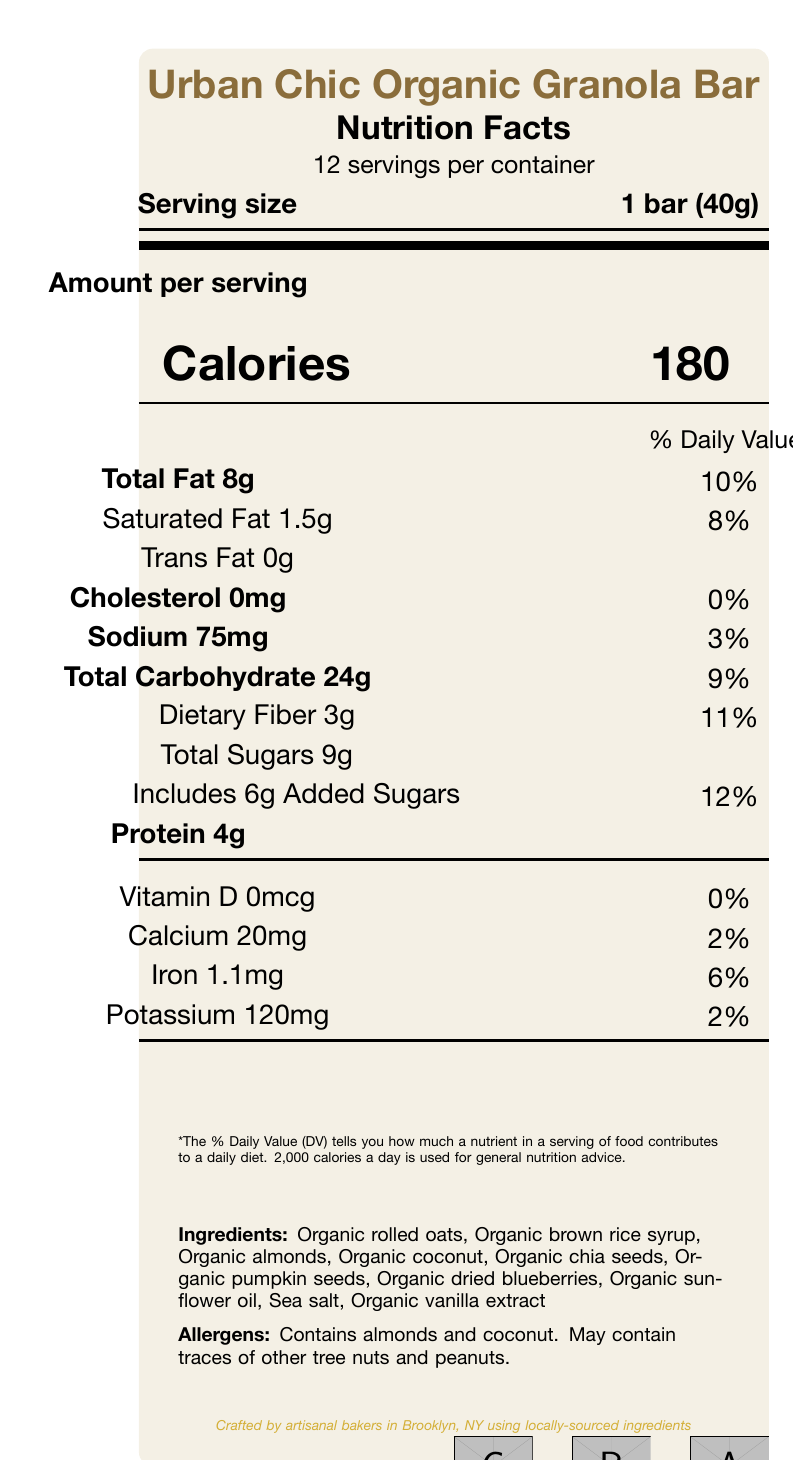What is the serving size for the Urban Chic Organic Granola Bar? The document states that the serving size is "1 bar (40g)."
Answer: 1 bar (40g) How many servings are there per container? It is mentioned that there are "12 servings per container."
Answer: 12 How many calories are in one serving of the granola bar? The document specifies the number of calories per serving as "180."
Answer: 180 What is the total amount of fat in one serving of the granola bar? The total fat amount for one serving is listed as "8g."
Answer: 8g How much sodium is in a single serving? The sodium content per serving is indicated as "75mg."
Answer: 75mg What percentage of the daily value of dietary fiber does one serving provide? The document shows that dietary fiber constitutes "11%" of the daily value in one serving.
Answer: 11% What are the main ingredients in the granola bar? The list of main ingredients is detailed in the document.
Answer: Organic rolled oats, Organic brown rice syrup, Organic almonds, Organic coconut, Organic chia seeds, Organic pumpkin seeds, Organic dried blueberries, Organic sunflower oil, Sea salt, Organic vanilla extract What allergens are mentioned in the granola bar? A. Peanuts B. Walnuts C. Almonds and coconut D. Soy The document specifies that the bar contains "almonds and coconut" and may contain traces of other tree nuts and peanuts.
Answer: C What is the primary color used in the color palette? A. #F4F0E5 B. #D4AF37 C. #8A6D3B D. #123456 The primary color specified is "#8A6D3B."
Answer: C Does the granola bar contain any trans fat? The document clearly states "Trans Fat 0g."
Answer: No How much protein does one granola bar contain? The protein content in one serving is listed as "4g."
Answer: 4g Does the granola bar contain vitamin D? The document indicates that the vitamin D content is "0mcg," equating to "0%."
Answer: No What are the certifications that the granola bar has received? The document lists these certifications under a section for certifications.
Answer: USDA Organic, Non-GMO Project Verified, Fair Trade Certified Describe the packaging of the granola bar. The document notes the packaging as "Recyclable kraft paper wrapper with gold foil accents."
Answer: Recyclable kraft paper wrapper with gold foil accents Who crafted the granola bar and where? The document's brand story states that the bar is crafted by artisanal bakers in Brooklyn using locally-sourced ingredients.
Answer: Artisanal bakers in Brooklyn, NY using locally-sourced ingredients How is the granola bar described to complement the kitchen decor? The designer note mentions this particular description.
Answer: Selected to complement your Scandinavian-inspired kitchen with its minimalist aesthetic and natural tones What is the percentage of the daily recommended value of calcium in one serving of the granola bar? The document specifies that one serving provides "2%" of the daily recommended value of calcium.
Answer: 2% Does the document provide the recommended daily intake for adults? The recommended daily intake for adults is not explicitly stated on the document.
Answer: No Summarize the main idea of the nutrition facts label. The document is a comprehensive nutrition facts label for an artisanal organic granola bar, highlighting key nutritional and ingredient information, allergens, packaging design, and certifications, with a touch of design aesthetics by noting how it complements a specific kitchen decor style.
Answer: The nutrition facts label provides detailed nutritional information about the Urban Chic Organic Granola Bar, including serving size, calories, amounts of various nutrients, ingredients, allergens, packaging, and certifications, all presented in a visually appealing manner to complement a Scandinavian-inspired kitchen. 